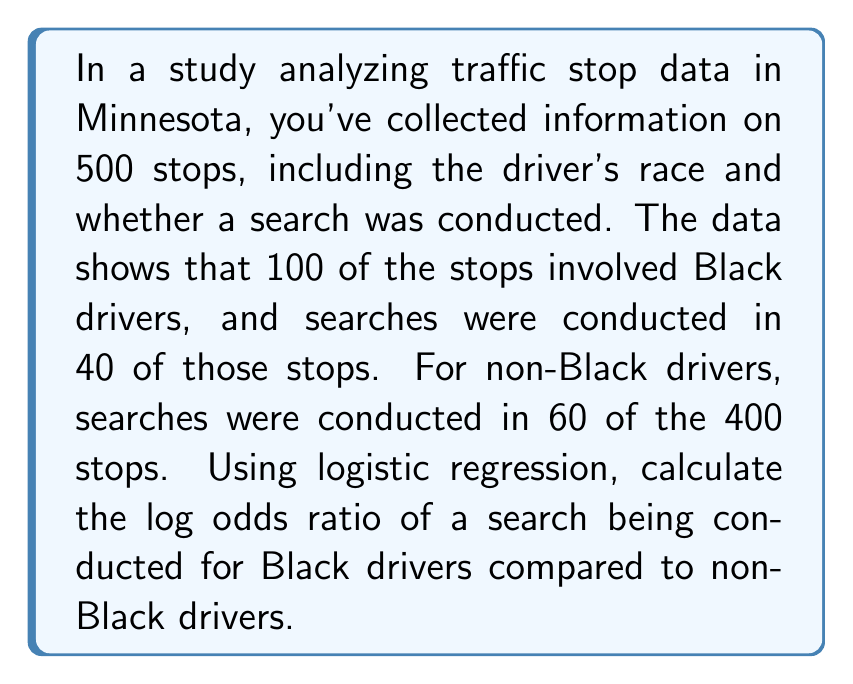Give your solution to this math problem. To solve this problem using logistic regression, we'll follow these steps:

1) First, let's organize our data:
   Black drivers: 40 searches out of 100 stops
   Non-Black drivers: 60 searches out of 400 stops

2) Calculate the odds for each group:
   Odds(Black) = 40 / (100 - 40) = 40 / 60 = 2/3
   Odds(Non-Black) = 60 / (400 - 60) = 60 / 340 = 3/17

3) Calculate the odds ratio:
   Odds Ratio = Odds(Black) / Odds(Non-Black)
   $$ \text{Odds Ratio} = \frac{2/3}{3/17} = \frac{2/3 \times 17/3}{1} = \frac{34}{9} \approx 3.778 $$

4) Calculate the log odds ratio:
   $$ \text{Log Odds Ratio} = \ln(\text{Odds Ratio}) = \ln(34/9) $$
   $$ = \ln(34) - \ln(9) $$
   $$ \approx 3.526 - 2.197 $$
   $$ \approx 1.329 $$

The log odds ratio is approximately 1.329, indicating that Black drivers are more likely to be searched during a traffic stop compared to non-Black drivers in this dataset.
Answer: 1.329 